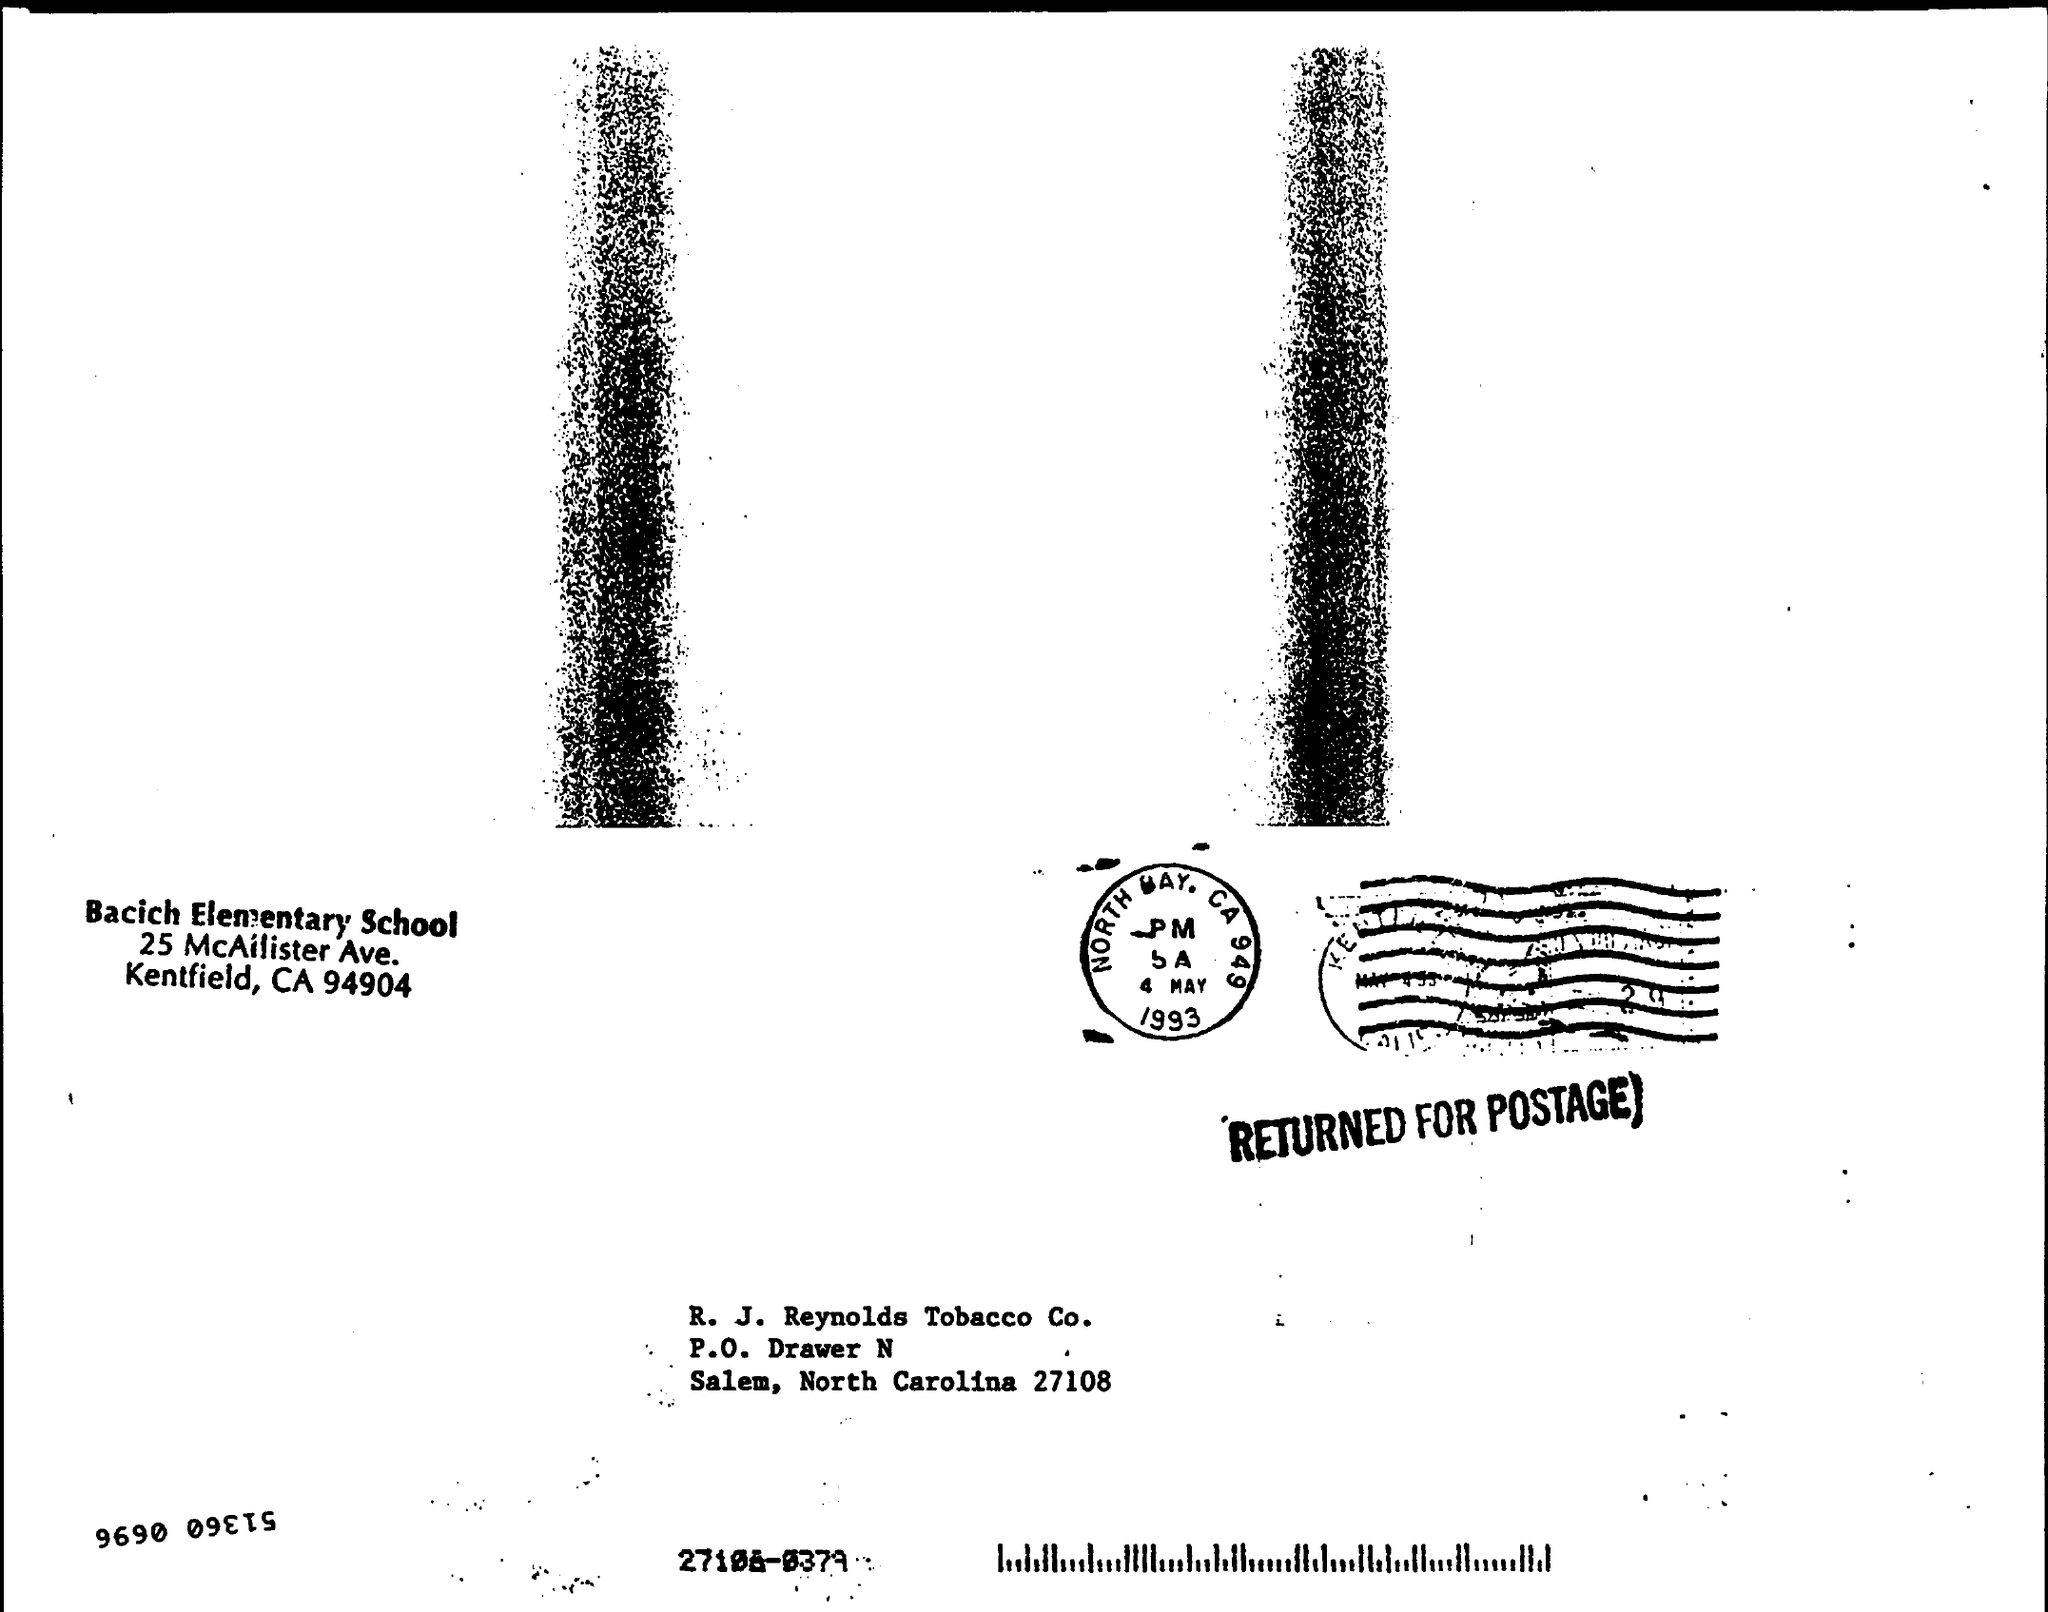Indicate a few pertinent items in this graphic. The date on the stamp is "4 May 1993. 